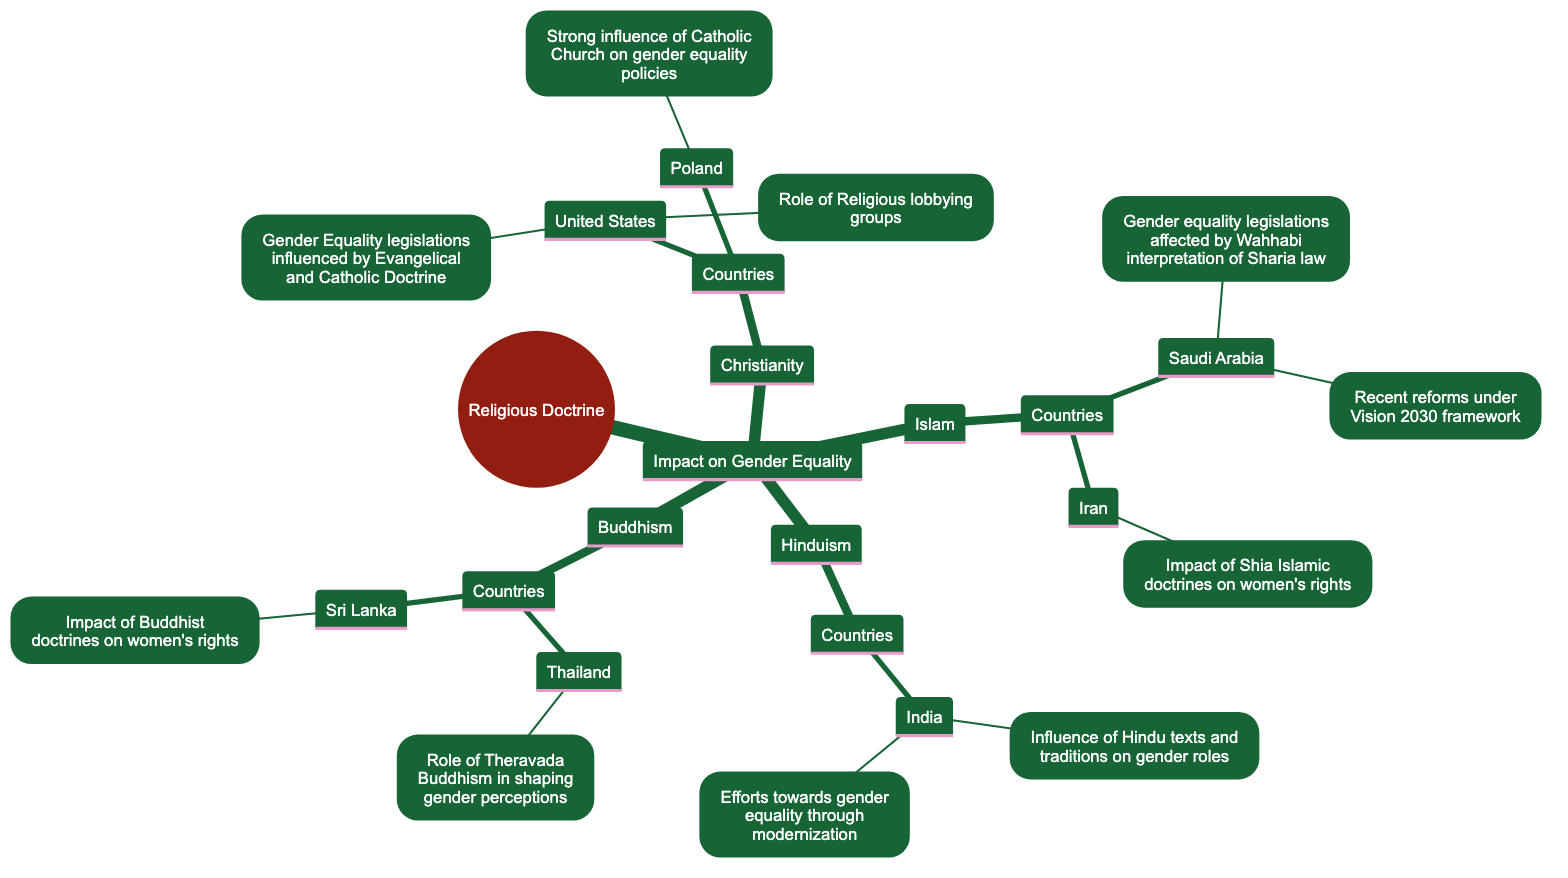What are the main religious doctrines influencing gender equality? The central node of the diagram is "Religious Doctrine," which branches out into different religious influences including Christianity, Islam, Hinduism, and Buddhism.
Answer: Christianity, Islam, Hinduism, Buddhism Which country is associated with the Catholic Church's influence on gender equality? The diagram shows that within the Christianity branch, Poland is highlighted as a country where the Catholic Church has a strong influence on gender equality policies.
Answer: Poland What recent reform is mentioned in relation to Saudi Arabia? In the Islam section, under Saudi Arabia, the diagram specifies "Recent reforms under Vision 2030 framework" as a recent change impacting gender equality.
Answer: Recent reforms under Vision 2030 framework How does Hinduism influence gender roles in India? Within the Hinduism section, the information indicates that Hindu texts and traditions significantly affect gender roles in India, including issues like the dowry system.
Answer: Influence of Hindu texts and traditions on gender roles What type of Buddhism's role is mentioned in the context of gender perceptions in Thailand? The diagram identifies that the "Role of Theravada Buddhism in shaping gender perceptions" is mentioned in the context of Thailand under the Buddhism section.
Answer: Theravada Buddhism What legislation impact is seen in the United States due to religious doctrines? The United States under Christianity is influenced by "Gender Equality legislations influenced by Evangelical and Catholic Doctrine" concerning various legislations like abortion and LGBTQ+ rights.
Answer: Gender Equality legislations influenced by Evangelical and Catholic Doctrine How many countries are listed under the influence of Islam? The Islam branch lists two countries: Saudi Arabia and Iran, making the total number of countries under this influence two.
Answer: 2 What influences women's rights in Iran according to the diagram? The diagram states that "Impact of Shia Islamic doctrines on women's rights" is the relevant influence affecting women's rights in Iran.
Answer: Impact of Shia Islamic doctrines on women's rights How does the diagram show the connection between religious doctrines and legislation? By illustrating branches and nodes, the diagram connects various religious doctrines (like Christianity and Islam) to specific countries and their corresponding gender equality legislations.
Answer: Religious doctrines linked to countries and legislations 